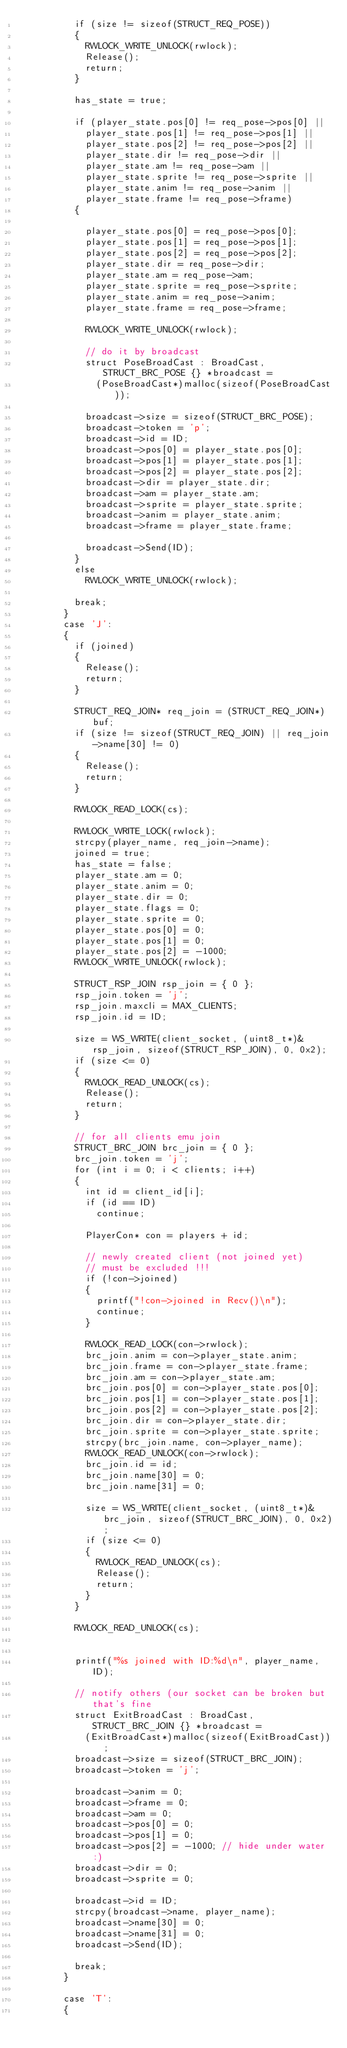Convert code to text. <code><loc_0><loc_0><loc_500><loc_500><_C++_>					if (size != sizeof(STRUCT_REQ_POSE))
					{
						RWLOCK_WRITE_UNLOCK(rwlock);
						Release();
						return;
					}

					has_state = true;

					if (player_state.pos[0] != req_pose->pos[0] ||
						player_state.pos[1] != req_pose->pos[1] ||
						player_state.pos[2] != req_pose->pos[2] ||
						player_state.dir != req_pose->dir ||
						player_state.am != req_pose->am ||
						player_state.sprite != req_pose->sprite ||
						player_state.anim != req_pose->anim ||
						player_state.frame != req_pose->frame)
					{

						player_state.pos[0] = req_pose->pos[0];
						player_state.pos[1] = req_pose->pos[1];
						player_state.pos[2] = req_pose->pos[2];
						player_state.dir = req_pose->dir;
						player_state.am = req_pose->am;
						player_state.sprite = req_pose->sprite;
						player_state.anim = req_pose->anim;
						player_state.frame = req_pose->frame;

						RWLOCK_WRITE_UNLOCK(rwlock);

						// do it by broadcast
						struct PoseBroadCast : BroadCast, STRUCT_BRC_POSE {} *broadcast =
							(PoseBroadCast*)malloc(sizeof(PoseBroadCast));

						broadcast->size = sizeof(STRUCT_BRC_POSE);
						broadcast->token = 'p';
						broadcast->id = ID;
						broadcast->pos[0] = player_state.pos[0];
						broadcast->pos[1] = player_state.pos[1];
						broadcast->pos[2] = player_state.pos[2];
						broadcast->dir = player_state.dir;
						broadcast->am = player_state.am;
						broadcast->sprite = player_state.sprite;
						broadcast->anim = player_state.anim;
						broadcast->frame = player_state.frame;

						broadcast->Send(ID);
					}
					else
						RWLOCK_WRITE_UNLOCK(rwlock);

					break;
				}
				case 'J':
				{
					if (joined)
					{
						Release();
						return;
					}

					STRUCT_REQ_JOIN* req_join = (STRUCT_REQ_JOIN*)buf;
					if (size != sizeof(STRUCT_REQ_JOIN) || req_join->name[30] != 0)
					{
						Release();
						return;
					}

					RWLOCK_READ_LOCK(cs);

					RWLOCK_WRITE_LOCK(rwlock);
					strcpy(player_name, req_join->name);
					joined = true;
					has_state = false;
					player_state.am = 0;
					player_state.anim = 0;
					player_state.dir = 0;
					player_state.flags = 0;
					player_state.sprite = 0;
					player_state.pos[0] = 0;
					player_state.pos[1] = 0;
					player_state.pos[2] = -1000;
					RWLOCK_WRITE_UNLOCK(rwlock);

					STRUCT_RSP_JOIN rsp_join = { 0 };
					rsp_join.token = 'j';
					rsp_join.maxcli = MAX_CLIENTS;
					rsp_join.id = ID;

					size = WS_WRITE(client_socket, (uint8_t*)&rsp_join, sizeof(STRUCT_RSP_JOIN), 0, 0x2);
					if (size <= 0)
					{
						RWLOCK_READ_UNLOCK(cs);
						Release();
						return;
					}

					// for all clients emu join
					STRUCT_BRC_JOIN brc_join = { 0 };
					brc_join.token = 'j';
					for (int i = 0; i < clients; i++)
					{
						int id = client_id[i];
						if (id == ID)
							continue;

						PlayerCon* con = players + id;

						// newly created client (not joined yet)
						// must be excluded !!!
						if (!con->joined)
						{
							printf("!con->joined in Recv()\n");
							continue;
						}
							
						RWLOCK_READ_LOCK(con->rwlock);
						brc_join.anim = con->player_state.anim;
						brc_join.frame = con->player_state.frame;
						brc_join.am = con->player_state.am;
						brc_join.pos[0] = con->player_state.pos[0];
						brc_join.pos[1] = con->player_state.pos[1];
						brc_join.pos[2] = con->player_state.pos[2];
						brc_join.dir = con->player_state.dir;
						brc_join.sprite = con->player_state.sprite;
						strcpy(brc_join.name, con->player_name);
						RWLOCK_READ_UNLOCK(con->rwlock);
						brc_join.id = id;
						brc_join.name[30] = 0;
						brc_join.name[31] = 0;

						size = WS_WRITE(client_socket, (uint8_t*)&brc_join, sizeof(STRUCT_BRC_JOIN), 0, 0x2);
						if (size <= 0)
						{
							RWLOCK_READ_UNLOCK(cs);
							Release();
							return;
						}
					}

					RWLOCK_READ_UNLOCK(cs);


					printf("%s joined with ID:%d\n", player_name, ID);

					// notify others (our socket can be broken but that's fine
					struct ExitBroadCast : BroadCast, STRUCT_BRC_JOIN {} *broadcast =
						(ExitBroadCast*)malloc(sizeof(ExitBroadCast));
					broadcast->size = sizeof(STRUCT_BRC_JOIN);
					broadcast->token = 'j';

					broadcast->anim = 0;
					broadcast->frame = 0;
					broadcast->am = 0;
					broadcast->pos[0] = 0;
					broadcast->pos[1] = 0;
					broadcast->pos[2] = -1000; // hide under water :)
					broadcast->dir = 0;
					broadcast->sprite = 0;

					broadcast->id = ID;
					strcpy(broadcast->name, player_name);
					broadcast->name[30] = 0;
					broadcast->name[31] = 0;
					broadcast->Send(ID);

					break;
				}

				case 'T':
				{</code> 